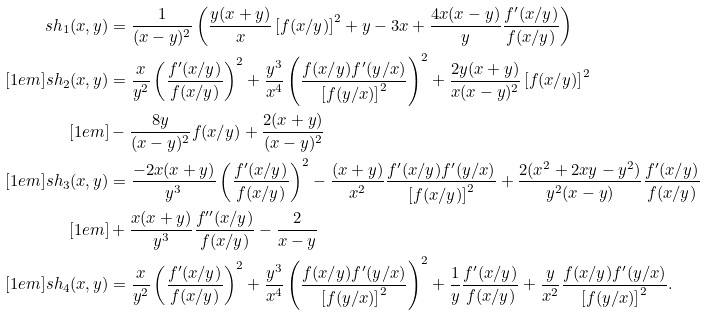Convert formula to latex. <formula><loc_0><loc_0><loc_500><loc_500>s h _ { 1 } ( x , y ) & = \frac { 1 } { ( x - y ) ^ { 2 } } \left ( \frac { y ( x + y ) } { x } \left [ f ( x / y ) \right ] ^ { 2 } + y - 3 x + \frac { 4 x ( x - y ) } { y } \frac { f ^ { \prime } ( x / y ) } { f ( x / y ) } \right ) \\ [ 1 e m ] s h _ { 2 } ( x , y ) & = \frac { x } { y ^ { 2 } } \left ( \frac { f ^ { \prime } ( x / y ) } { f ( x / y ) } \right ) ^ { 2 } + \frac { y ^ { 3 } } { x ^ { 4 } } \left ( \frac { f ( x / y ) f ^ { \prime } ( y / x ) } { \left [ f ( y / x ) \right ] ^ { 2 } } \right ) ^ { 2 } + \frac { 2 y ( x + y ) } { x ( x - y ) ^ { 2 } } \left [ f ( x / y ) \right ] ^ { 2 } \\ [ 1 e m ] & - \frac { 8 y } { ( x - y ) ^ { 2 } } f ( x / y ) + \frac { 2 ( x + y ) } { ( x - y ) ^ { 2 } } \\ [ 1 e m ] s h _ { 3 } ( x , y ) & = \frac { - 2 x ( x + y ) } { y ^ { 3 } } \left ( \frac { f ^ { \prime } ( x / y ) } { f ( x / y ) } \right ) ^ { 2 } - \frac { ( x + y ) } { x ^ { 2 } } \frac { f ^ { \prime } ( x / y ) f ^ { \prime } ( y / x ) } { \left [ f ( x / y ) \right ] ^ { 2 } } + \frac { 2 ( x ^ { 2 } + 2 x y - y ^ { 2 } ) } { y ^ { 2 } ( x - y ) } \frac { f ^ { \prime } ( x / y ) } { f ( x / y ) } \\ [ 1 e m ] & + \frac { x ( x + y ) } { y ^ { 3 } } \frac { f ^ { \prime \prime } ( x / y ) } { f ( x / y ) } - \frac { 2 } { x - y } \\ [ 1 e m ] s h _ { 4 } ( x , y ) & = \frac { x } { y ^ { 2 } } \left ( \frac { f ^ { \prime } ( x / y ) } { f ( x / y ) } \right ) ^ { 2 } + \frac { y ^ { 3 } } { x ^ { 4 } } \left ( \frac { f ( x / y ) f ^ { \prime } ( y / x ) } { \left [ f ( y / x ) \right ] ^ { 2 } } \right ) ^ { 2 } + \frac { 1 } { y } \frac { f ^ { \prime } ( x / y ) } { f ( x / y ) } + \frac { y } { x ^ { 2 } } \frac { f ( x / y ) f ^ { \prime } ( y / x ) } { \left [ f ( y / x ) \right ] ^ { 2 } } .</formula> 